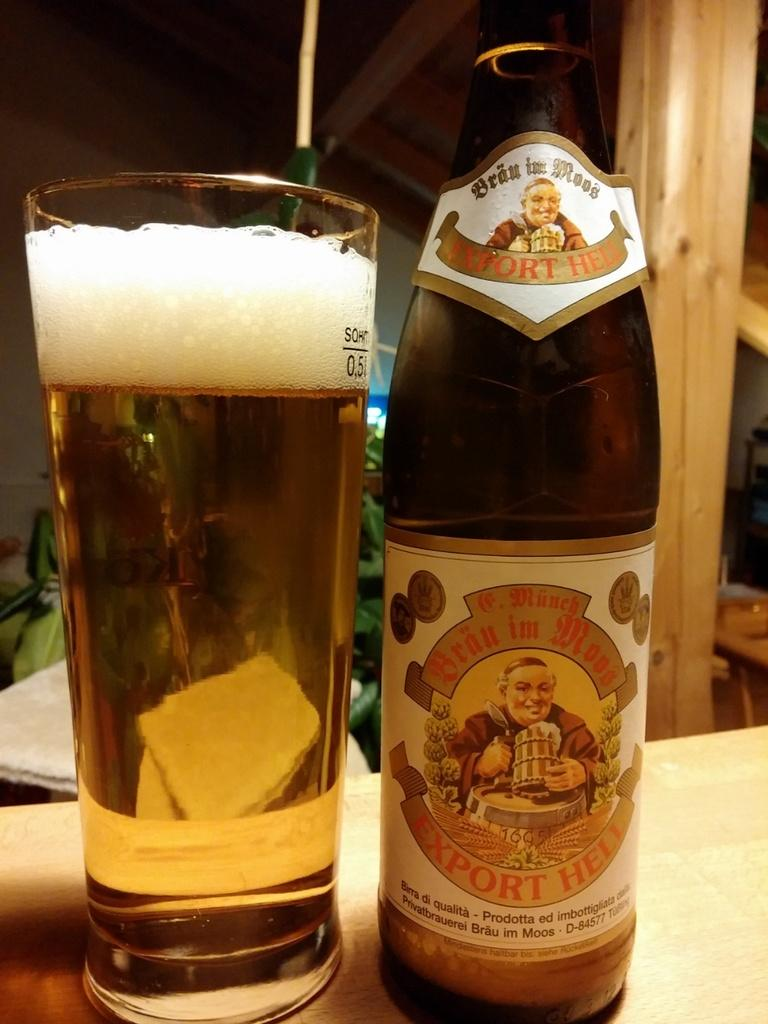<image>
Create a compact narrative representing the image presented. a bottle of export heli beer next to a glass 